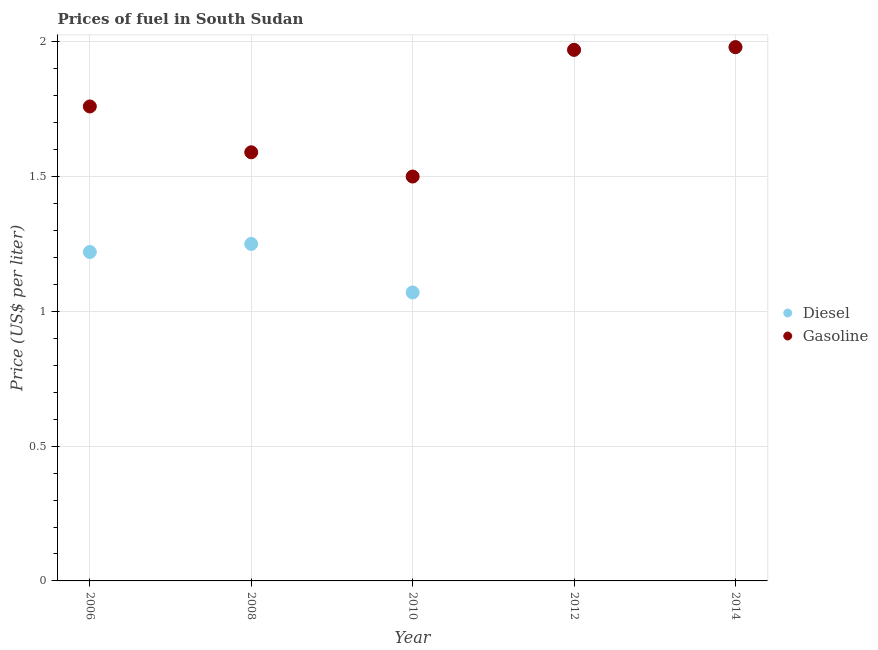Across all years, what is the maximum diesel price?
Keep it short and to the point. 1.98. Across all years, what is the minimum gasoline price?
Provide a short and direct response. 1.5. In which year was the diesel price maximum?
Provide a short and direct response. 2014. What is the total diesel price in the graph?
Your answer should be very brief. 7.49. What is the difference between the diesel price in 2010 and that in 2014?
Offer a very short reply. -0.91. What is the difference between the diesel price in 2010 and the gasoline price in 2006?
Make the answer very short. -0.69. What is the average gasoline price per year?
Make the answer very short. 1.76. In the year 2006, what is the difference between the gasoline price and diesel price?
Provide a succinct answer. 0.54. In how many years, is the gasoline price greater than 1.6 US$ per litre?
Your answer should be compact. 3. What is the ratio of the gasoline price in 2008 to that in 2010?
Provide a succinct answer. 1.06. Is the difference between the gasoline price in 2012 and 2014 greater than the difference between the diesel price in 2012 and 2014?
Your response must be concise. No. What is the difference between the highest and the second highest diesel price?
Keep it short and to the point. 0.01. What is the difference between the highest and the lowest diesel price?
Ensure brevity in your answer.  0.91. In how many years, is the diesel price greater than the average diesel price taken over all years?
Provide a succinct answer. 2. Does the diesel price monotonically increase over the years?
Provide a succinct answer. No. Is the gasoline price strictly less than the diesel price over the years?
Provide a short and direct response. No. How many dotlines are there?
Keep it short and to the point. 2. How many years are there in the graph?
Offer a terse response. 5. What is the difference between two consecutive major ticks on the Y-axis?
Provide a short and direct response. 0.5. Does the graph contain grids?
Ensure brevity in your answer.  Yes. What is the title of the graph?
Your answer should be very brief. Prices of fuel in South Sudan. What is the label or title of the X-axis?
Your response must be concise. Year. What is the label or title of the Y-axis?
Make the answer very short. Price (US$ per liter). What is the Price (US$ per liter) of Diesel in 2006?
Offer a terse response. 1.22. What is the Price (US$ per liter) in Gasoline in 2006?
Your answer should be very brief. 1.76. What is the Price (US$ per liter) of Gasoline in 2008?
Make the answer very short. 1.59. What is the Price (US$ per liter) of Diesel in 2010?
Provide a succinct answer. 1.07. What is the Price (US$ per liter) of Diesel in 2012?
Offer a very short reply. 1.97. What is the Price (US$ per liter) of Gasoline in 2012?
Ensure brevity in your answer.  1.97. What is the Price (US$ per liter) of Diesel in 2014?
Provide a succinct answer. 1.98. What is the Price (US$ per liter) of Gasoline in 2014?
Keep it short and to the point. 1.98. Across all years, what is the maximum Price (US$ per liter) of Diesel?
Keep it short and to the point. 1.98. Across all years, what is the maximum Price (US$ per liter) in Gasoline?
Provide a succinct answer. 1.98. Across all years, what is the minimum Price (US$ per liter) of Diesel?
Provide a short and direct response. 1.07. What is the total Price (US$ per liter) in Diesel in the graph?
Offer a terse response. 7.49. What is the total Price (US$ per liter) of Gasoline in the graph?
Give a very brief answer. 8.8. What is the difference between the Price (US$ per liter) of Diesel in 2006 and that in 2008?
Make the answer very short. -0.03. What is the difference between the Price (US$ per liter) in Gasoline in 2006 and that in 2008?
Your answer should be compact. 0.17. What is the difference between the Price (US$ per liter) in Gasoline in 2006 and that in 2010?
Ensure brevity in your answer.  0.26. What is the difference between the Price (US$ per liter) of Diesel in 2006 and that in 2012?
Provide a succinct answer. -0.75. What is the difference between the Price (US$ per liter) of Gasoline in 2006 and that in 2012?
Your response must be concise. -0.21. What is the difference between the Price (US$ per liter) in Diesel in 2006 and that in 2014?
Your answer should be compact. -0.76. What is the difference between the Price (US$ per liter) in Gasoline in 2006 and that in 2014?
Keep it short and to the point. -0.22. What is the difference between the Price (US$ per liter) of Diesel in 2008 and that in 2010?
Provide a short and direct response. 0.18. What is the difference between the Price (US$ per liter) of Gasoline in 2008 and that in 2010?
Offer a terse response. 0.09. What is the difference between the Price (US$ per liter) of Diesel in 2008 and that in 2012?
Provide a short and direct response. -0.72. What is the difference between the Price (US$ per liter) of Gasoline in 2008 and that in 2012?
Your response must be concise. -0.38. What is the difference between the Price (US$ per liter) in Diesel in 2008 and that in 2014?
Keep it short and to the point. -0.73. What is the difference between the Price (US$ per liter) of Gasoline in 2008 and that in 2014?
Provide a succinct answer. -0.39. What is the difference between the Price (US$ per liter) of Gasoline in 2010 and that in 2012?
Provide a short and direct response. -0.47. What is the difference between the Price (US$ per liter) of Diesel in 2010 and that in 2014?
Offer a terse response. -0.91. What is the difference between the Price (US$ per liter) of Gasoline in 2010 and that in 2014?
Ensure brevity in your answer.  -0.48. What is the difference between the Price (US$ per liter) of Diesel in 2012 and that in 2014?
Your answer should be very brief. -0.01. What is the difference between the Price (US$ per liter) in Gasoline in 2012 and that in 2014?
Your answer should be compact. -0.01. What is the difference between the Price (US$ per liter) in Diesel in 2006 and the Price (US$ per liter) in Gasoline in 2008?
Ensure brevity in your answer.  -0.37. What is the difference between the Price (US$ per liter) of Diesel in 2006 and the Price (US$ per liter) of Gasoline in 2010?
Your answer should be compact. -0.28. What is the difference between the Price (US$ per liter) of Diesel in 2006 and the Price (US$ per liter) of Gasoline in 2012?
Offer a very short reply. -0.75. What is the difference between the Price (US$ per liter) in Diesel in 2006 and the Price (US$ per liter) in Gasoline in 2014?
Offer a terse response. -0.76. What is the difference between the Price (US$ per liter) of Diesel in 2008 and the Price (US$ per liter) of Gasoline in 2010?
Your answer should be very brief. -0.25. What is the difference between the Price (US$ per liter) of Diesel in 2008 and the Price (US$ per liter) of Gasoline in 2012?
Give a very brief answer. -0.72. What is the difference between the Price (US$ per liter) in Diesel in 2008 and the Price (US$ per liter) in Gasoline in 2014?
Give a very brief answer. -0.73. What is the difference between the Price (US$ per liter) in Diesel in 2010 and the Price (US$ per liter) in Gasoline in 2012?
Offer a terse response. -0.9. What is the difference between the Price (US$ per liter) of Diesel in 2010 and the Price (US$ per liter) of Gasoline in 2014?
Your answer should be compact. -0.91. What is the difference between the Price (US$ per liter) of Diesel in 2012 and the Price (US$ per liter) of Gasoline in 2014?
Make the answer very short. -0.01. What is the average Price (US$ per liter) in Diesel per year?
Give a very brief answer. 1.5. What is the average Price (US$ per liter) in Gasoline per year?
Provide a succinct answer. 1.76. In the year 2006, what is the difference between the Price (US$ per liter) in Diesel and Price (US$ per liter) in Gasoline?
Ensure brevity in your answer.  -0.54. In the year 2008, what is the difference between the Price (US$ per liter) in Diesel and Price (US$ per liter) in Gasoline?
Provide a short and direct response. -0.34. In the year 2010, what is the difference between the Price (US$ per liter) in Diesel and Price (US$ per liter) in Gasoline?
Provide a short and direct response. -0.43. In the year 2014, what is the difference between the Price (US$ per liter) of Diesel and Price (US$ per liter) of Gasoline?
Your response must be concise. 0. What is the ratio of the Price (US$ per liter) in Gasoline in 2006 to that in 2008?
Keep it short and to the point. 1.11. What is the ratio of the Price (US$ per liter) of Diesel in 2006 to that in 2010?
Your answer should be compact. 1.14. What is the ratio of the Price (US$ per liter) in Gasoline in 2006 to that in 2010?
Provide a short and direct response. 1.17. What is the ratio of the Price (US$ per liter) in Diesel in 2006 to that in 2012?
Your answer should be compact. 0.62. What is the ratio of the Price (US$ per liter) in Gasoline in 2006 to that in 2012?
Provide a succinct answer. 0.89. What is the ratio of the Price (US$ per liter) of Diesel in 2006 to that in 2014?
Offer a very short reply. 0.62. What is the ratio of the Price (US$ per liter) in Diesel in 2008 to that in 2010?
Make the answer very short. 1.17. What is the ratio of the Price (US$ per liter) of Gasoline in 2008 to that in 2010?
Make the answer very short. 1.06. What is the ratio of the Price (US$ per liter) in Diesel in 2008 to that in 2012?
Provide a short and direct response. 0.63. What is the ratio of the Price (US$ per liter) of Gasoline in 2008 to that in 2012?
Offer a very short reply. 0.81. What is the ratio of the Price (US$ per liter) in Diesel in 2008 to that in 2014?
Provide a short and direct response. 0.63. What is the ratio of the Price (US$ per liter) of Gasoline in 2008 to that in 2014?
Keep it short and to the point. 0.8. What is the ratio of the Price (US$ per liter) in Diesel in 2010 to that in 2012?
Keep it short and to the point. 0.54. What is the ratio of the Price (US$ per liter) in Gasoline in 2010 to that in 2012?
Your answer should be very brief. 0.76. What is the ratio of the Price (US$ per liter) of Diesel in 2010 to that in 2014?
Offer a very short reply. 0.54. What is the ratio of the Price (US$ per liter) of Gasoline in 2010 to that in 2014?
Offer a terse response. 0.76. What is the difference between the highest and the lowest Price (US$ per liter) of Diesel?
Give a very brief answer. 0.91. What is the difference between the highest and the lowest Price (US$ per liter) of Gasoline?
Make the answer very short. 0.48. 